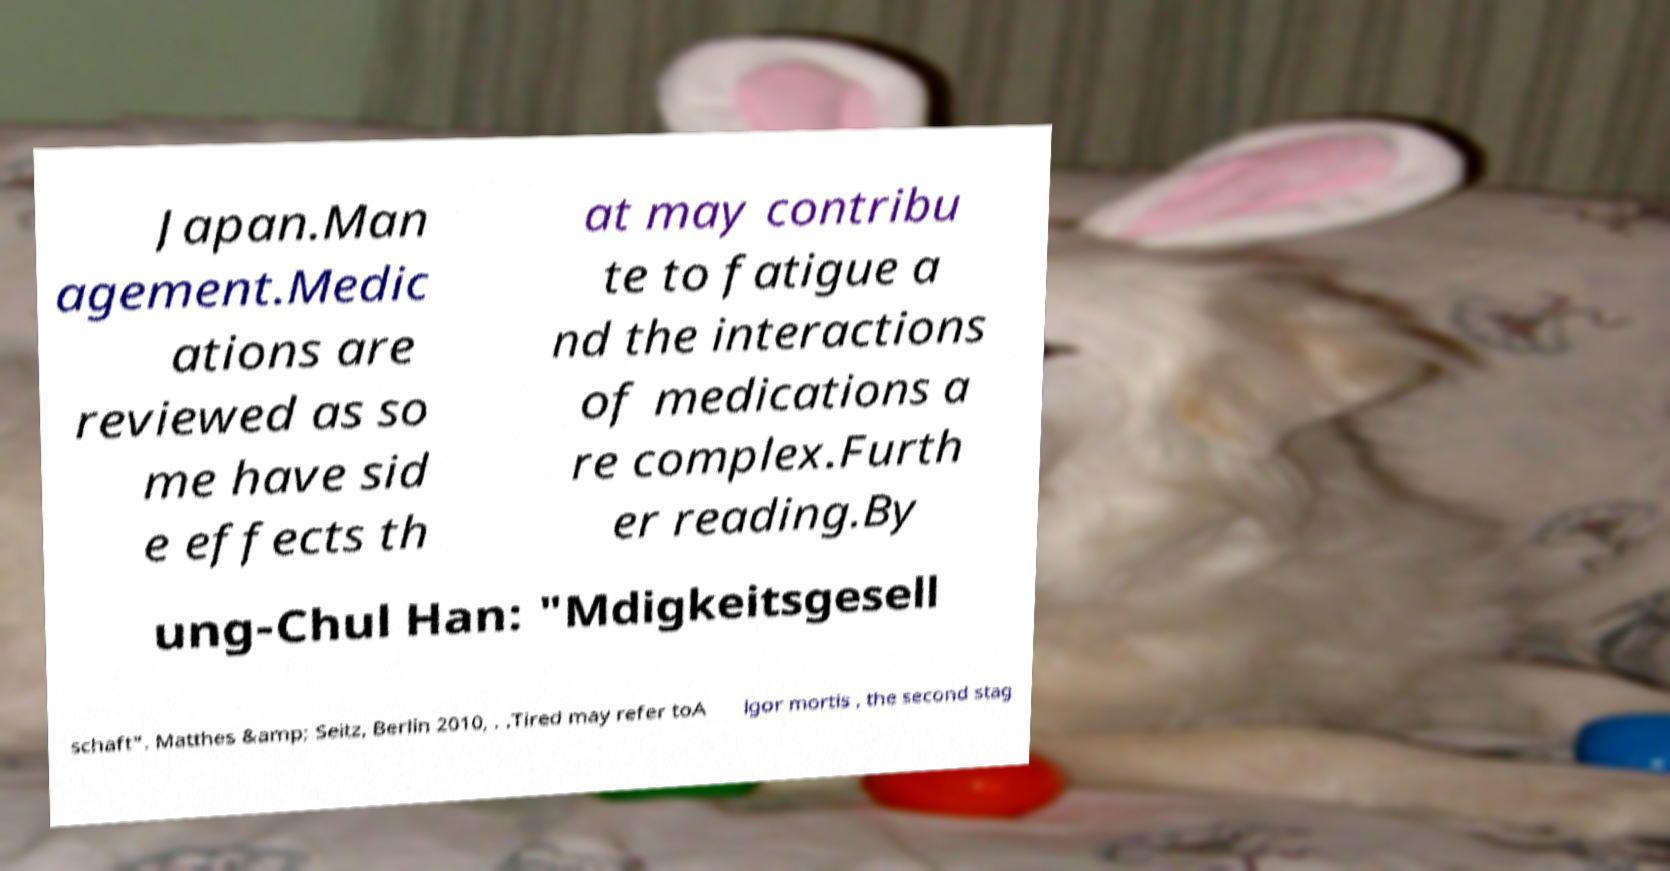Could you assist in decoding the text presented in this image and type it out clearly? Japan.Man agement.Medic ations are reviewed as so me have sid e effects th at may contribu te to fatigue a nd the interactions of medications a re complex.Furth er reading.By ung-Chul Han: "Mdigkeitsgesell schaft". Matthes &amp; Seitz, Berlin 2010, . .Tired may refer toA lgor mortis , the second stag 